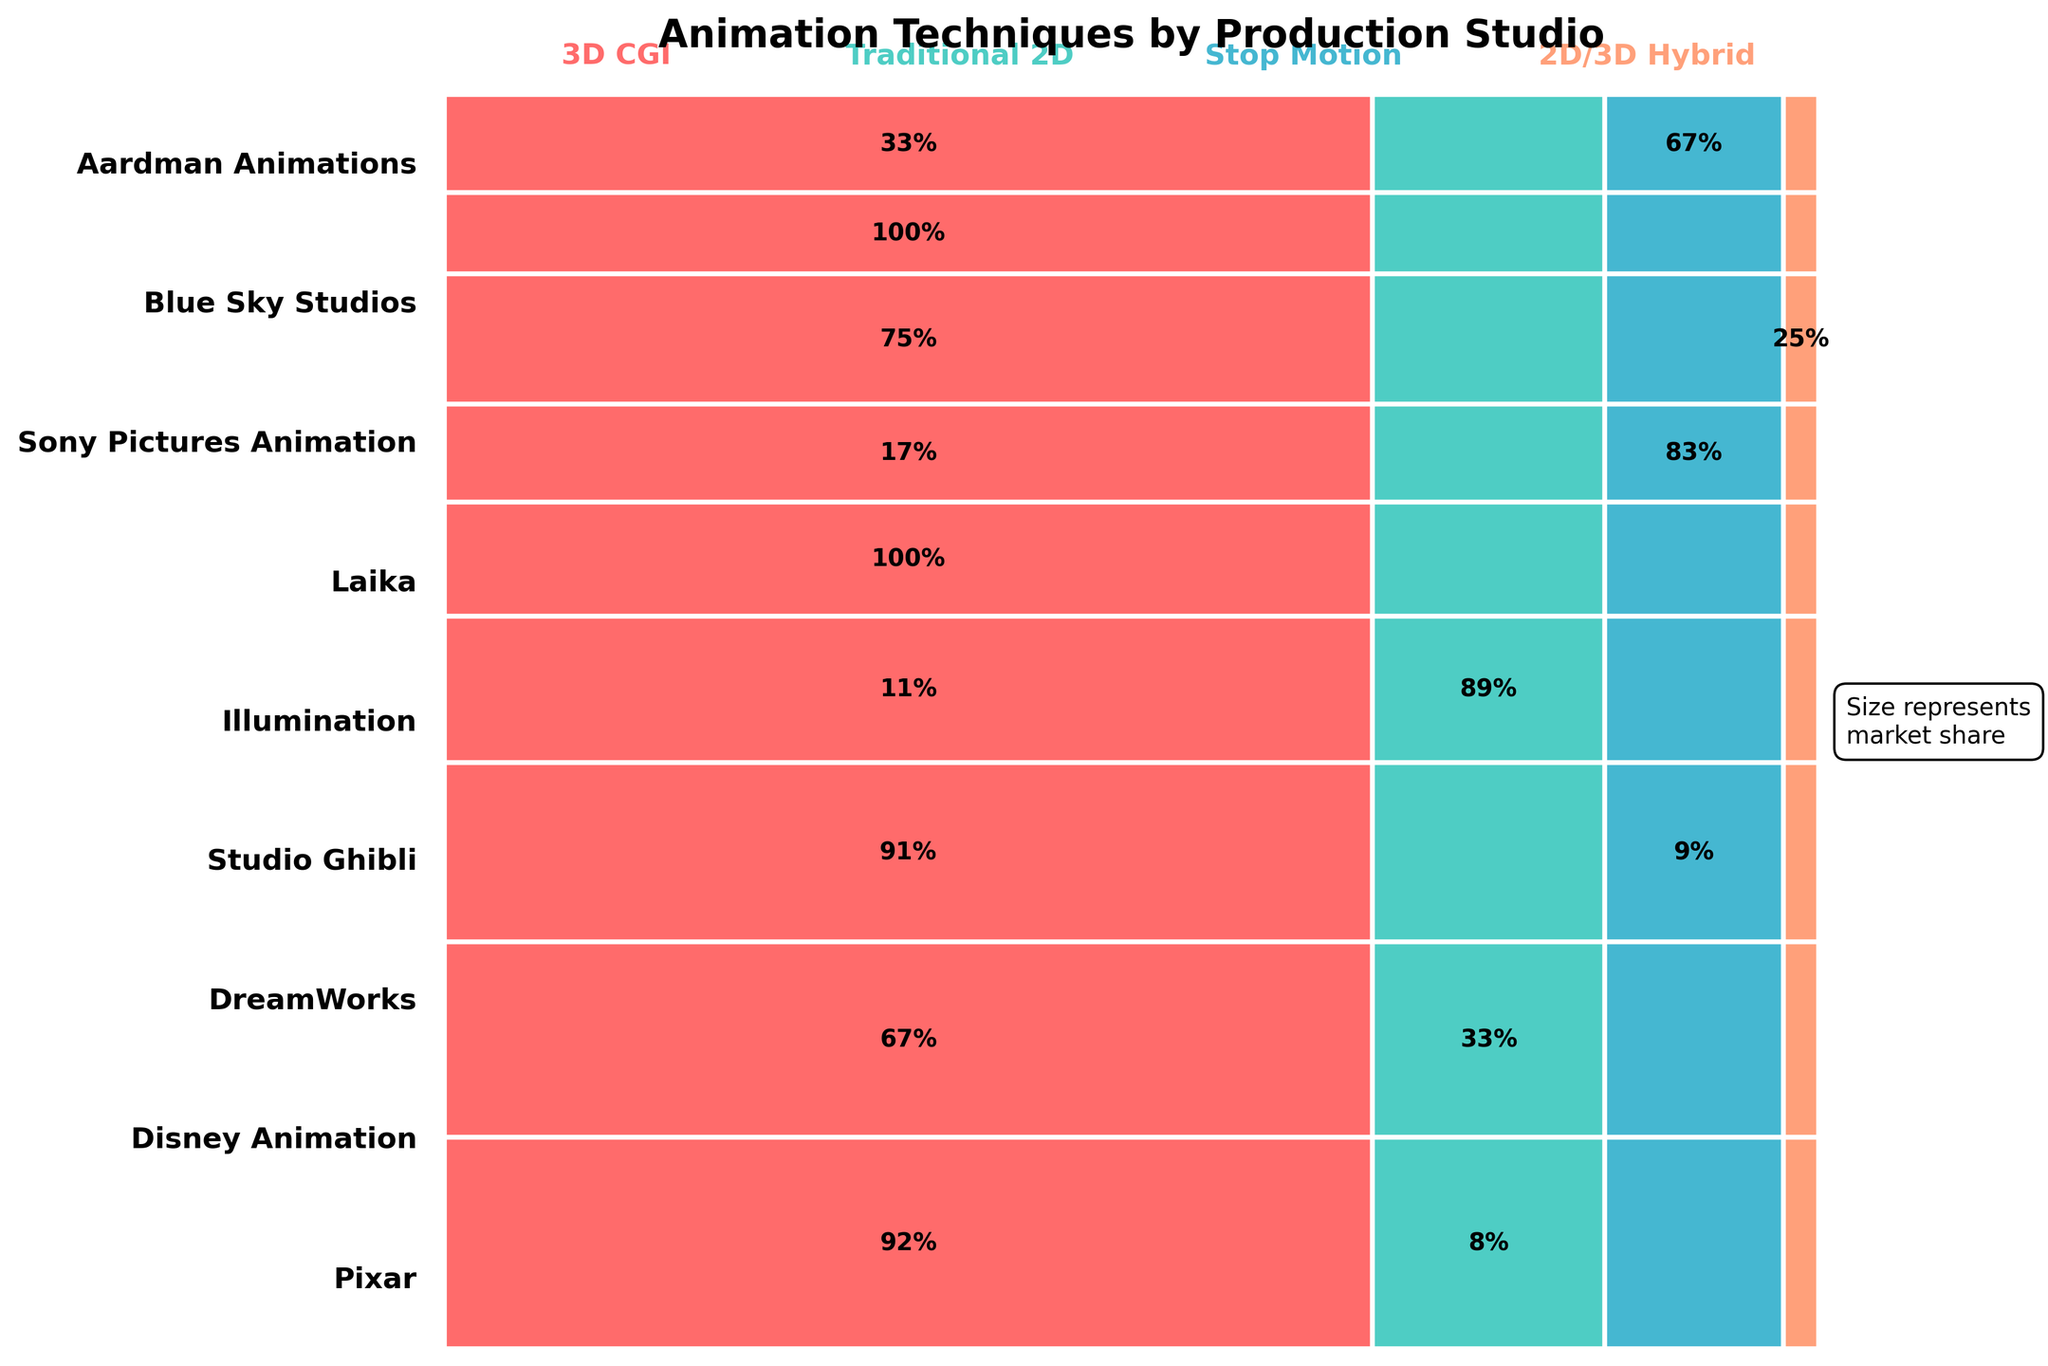What animation technique does Pixar use most frequently? From the figure, you can see the larger portion of Pixar's segment is colored representing 3D CGI. This indicates that most of its films use the 3D CGI technique.
Answer: 3D CGI Which studio has used a 2D/3D Hybrid technique for its top-grossing films? The figure shows that only Sony Pictures Animation has a segment colored for the 2D/3D Hybrid technique.
Answer: Sony Pictures Animation How many studios use Stop Motion animation at least once? Stop Motion animation segments can be seen in the figure under DreamWorks, Laika, and Aardman Animations. Counting these segments, we get three studios.
Answer: 3 Which animation technique is used the least frequently? Look at the smallest segment representing an animation technique across all the studios. The smallest segment corresponds to the Traditional 2D technique used by Pixar.
Answer: Traditional 2D Between Pixar and Disney Animation, which studio has a greater proportion of 3D CGI films? By comparing the sizes of the segments representing 3D CGI for both Pixar and Disney Animation, Pixar has a larger proportion of 3D CGI films compared to Disney Animation.
Answer: Pixar What percentage of Studio Ghibli's films are 3D CGI? The figure shows Studio Ghibli's 3D CGI segment is smaller relative to its Traditional 2D part. Additionally, it is indicated by the value in the segment that 11% of Studio Ghibli’s films are 3D CGI.
Answer: 11% Which studios use only one animation technique? By checking the figure, Laika is shown using only Stop Motion, and Illumination uses only 3D CGI for their films. These studios do not have any other technique segments.
Answer: Laika, Illumination Compare the usage of Traditional 2D animation between Disney Animation and Studio Ghibli. Disney Animation's segment of Traditional 2D is colored and larger compared to the same segment for Studio Ghibli. So Disney Animation uses Traditional 2D more frequently.
Answer: Disney Animation Which animation technique has the largest market share across all studios? The largest segments across all studios in the figure represent 3D CGI. This indicates that 3D CGI holds the largest market share.
Answer: 3D CGI 